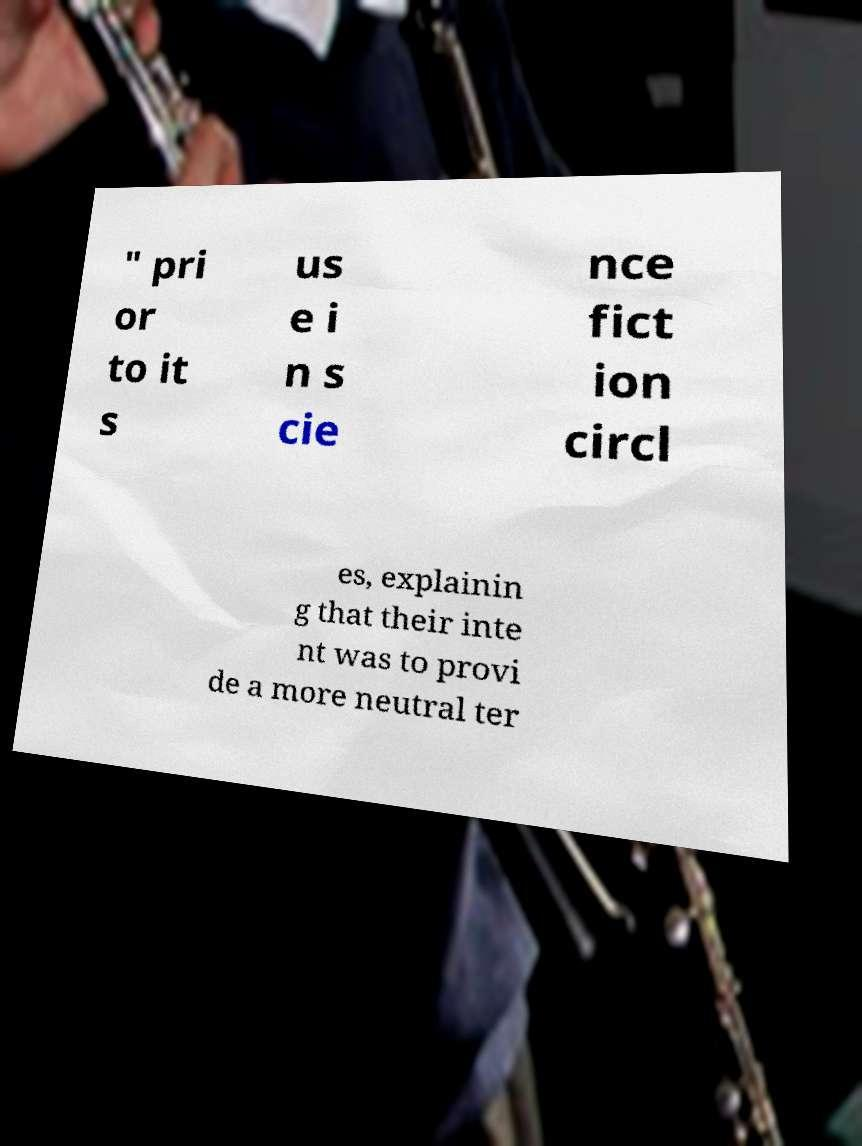For documentation purposes, I need the text within this image transcribed. Could you provide that? " pri or to it s us e i n s cie nce fict ion circl es, explainin g that their inte nt was to provi de a more neutral ter 